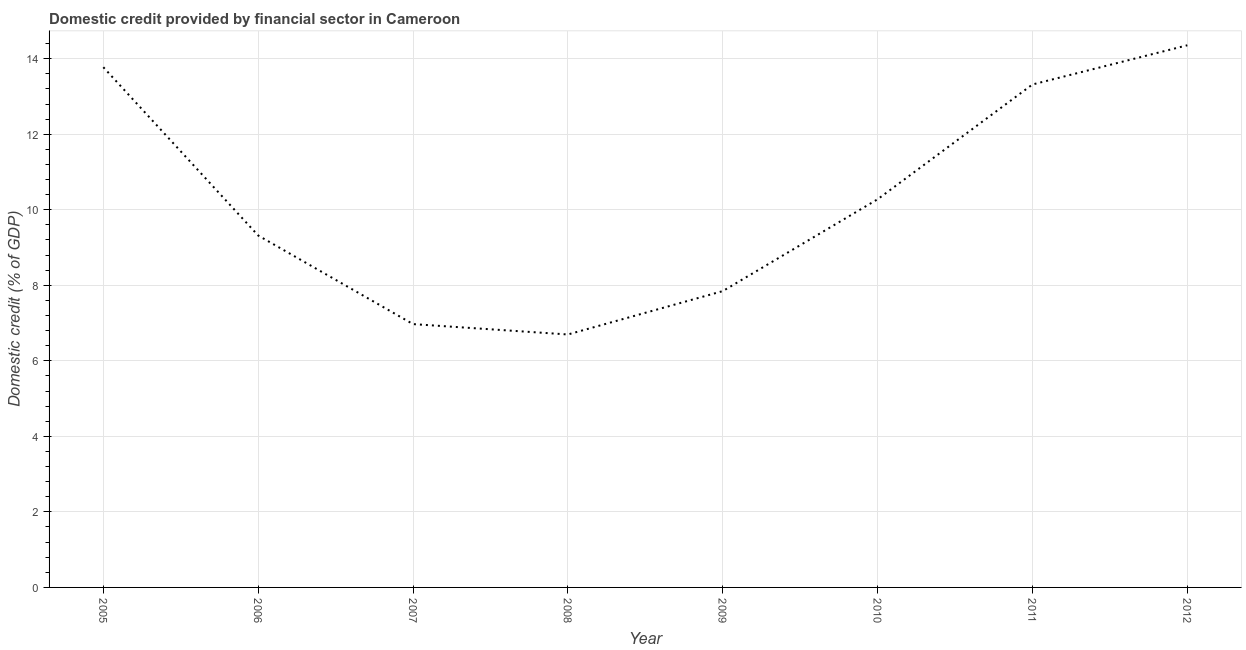What is the domestic credit provided by financial sector in 2010?
Provide a short and direct response. 10.28. Across all years, what is the maximum domestic credit provided by financial sector?
Provide a short and direct response. 14.35. Across all years, what is the minimum domestic credit provided by financial sector?
Provide a succinct answer. 6.7. In which year was the domestic credit provided by financial sector maximum?
Give a very brief answer. 2012. What is the sum of the domestic credit provided by financial sector?
Ensure brevity in your answer.  82.56. What is the difference between the domestic credit provided by financial sector in 2005 and 2011?
Your answer should be compact. 0.46. What is the average domestic credit provided by financial sector per year?
Offer a very short reply. 10.32. What is the median domestic credit provided by financial sector?
Provide a succinct answer. 9.8. In how many years, is the domestic credit provided by financial sector greater than 10.4 %?
Make the answer very short. 3. Do a majority of the years between 2012 and 2008 (inclusive) have domestic credit provided by financial sector greater than 8 %?
Ensure brevity in your answer.  Yes. What is the ratio of the domestic credit provided by financial sector in 2008 to that in 2011?
Your answer should be very brief. 0.5. Is the domestic credit provided by financial sector in 2005 less than that in 2011?
Keep it short and to the point. No. Is the difference between the domestic credit provided by financial sector in 2009 and 2012 greater than the difference between any two years?
Make the answer very short. No. What is the difference between the highest and the second highest domestic credit provided by financial sector?
Ensure brevity in your answer.  0.58. What is the difference between the highest and the lowest domestic credit provided by financial sector?
Keep it short and to the point. 7.66. In how many years, is the domestic credit provided by financial sector greater than the average domestic credit provided by financial sector taken over all years?
Give a very brief answer. 3. Does the domestic credit provided by financial sector monotonically increase over the years?
Ensure brevity in your answer.  No. How many lines are there?
Your answer should be compact. 1. Does the graph contain any zero values?
Your answer should be compact. No. Does the graph contain grids?
Provide a short and direct response. Yes. What is the title of the graph?
Give a very brief answer. Domestic credit provided by financial sector in Cameroon. What is the label or title of the Y-axis?
Give a very brief answer. Domestic credit (% of GDP). What is the Domestic credit (% of GDP) in 2005?
Your answer should be very brief. 13.77. What is the Domestic credit (% of GDP) of 2006?
Your response must be concise. 9.32. What is the Domestic credit (% of GDP) in 2007?
Provide a short and direct response. 6.97. What is the Domestic credit (% of GDP) in 2008?
Your answer should be compact. 6.7. What is the Domestic credit (% of GDP) in 2009?
Give a very brief answer. 7.85. What is the Domestic credit (% of GDP) of 2010?
Your response must be concise. 10.28. What is the Domestic credit (% of GDP) of 2011?
Offer a very short reply. 13.32. What is the Domestic credit (% of GDP) of 2012?
Make the answer very short. 14.35. What is the difference between the Domestic credit (% of GDP) in 2005 and 2006?
Make the answer very short. 4.46. What is the difference between the Domestic credit (% of GDP) in 2005 and 2007?
Your answer should be compact. 6.8. What is the difference between the Domestic credit (% of GDP) in 2005 and 2008?
Keep it short and to the point. 7.08. What is the difference between the Domestic credit (% of GDP) in 2005 and 2009?
Provide a succinct answer. 5.93. What is the difference between the Domestic credit (% of GDP) in 2005 and 2010?
Your response must be concise. 3.5. What is the difference between the Domestic credit (% of GDP) in 2005 and 2011?
Give a very brief answer. 0.46. What is the difference between the Domestic credit (% of GDP) in 2005 and 2012?
Your answer should be very brief. -0.58. What is the difference between the Domestic credit (% of GDP) in 2006 and 2007?
Provide a succinct answer. 2.35. What is the difference between the Domestic credit (% of GDP) in 2006 and 2008?
Make the answer very short. 2.62. What is the difference between the Domestic credit (% of GDP) in 2006 and 2009?
Provide a short and direct response. 1.47. What is the difference between the Domestic credit (% of GDP) in 2006 and 2010?
Your answer should be compact. -0.96. What is the difference between the Domestic credit (% of GDP) in 2006 and 2011?
Keep it short and to the point. -4. What is the difference between the Domestic credit (% of GDP) in 2006 and 2012?
Ensure brevity in your answer.  -5.04. What is the difference between the Domestic credit (% of GDP) in 2007 and 2008?
Your response must be concise. 0.27. What is the difference between the Domestic credit (% of GDP) in 2007 and 2009?
Your answer should be very brief. -0.87. What is the difference between the Domestic credit (% of GDP) in 2007 and 2010?
Provide a short and direct response. -3.31. What is the difference between the Domestic credit (% of GDP) in 2007 and 2011?
Offer a very short reply. -6.34. What is the difference between the Domestic credit (% of GDP) in 2007 and 2012?
Your answer should be very brief. -7.38. What is the difference between the Domestic credit (% of GDP) in 2008 and 2009?
Ensure brevity in your answer.  -1.15. What is the difference between the Domestic credit (% of GDP) in 2008 and 2010?
Your answer should be compact. -3.58. What is the difference between the Domestic credit (% of GDP) in 2008 and 2011?
Provide a succinct answer. -6.62. What is the difference between the Domestic credit (% of GDP) in 2008 and 2012?
Ensure brevity in your answer.  -7.66. What is the difference between the Domestic credit (% of GDP) in 2009 and 2010?
Ensure brevity in your answer.  -2.43. What is the difference between the Domestic credit (% of GDP) in 2009 and 2011?
Offer a terse response. -5.47. What is the difference between the Domestic credit (% of GDP) in 2009 and 2012?
Give a very brief answer. -6.51. What is the difference between the Domestic credit (% of GDP) in 2010 and 2011?
Ensure brevity in your answer.  -3.04. What is the difference between the Domestic credit (% of GDP) in 2010 and 2012?
Offer a terse response. -4.08. What is the difference between the Domestic credit (% of GDP) in 2011 and 2012?
Your answer should be compact. -1.04. What is the ratio of the Domestic credit (% of GDP) in 2005 to that in 2006?
Ensure brevity in your answer.  1.48. What is the ratio of the Domestic credit (% of GDP) in 2005 to that in 2007?
Offer a terse response. 1.98. What is the ratio of the Domestic credit (% of GDP) in 2005 to that in 2008?
Keep it short and to the point. 2.06. What is the ratio of the Domestic credit (% of GDP) in 2005 to that in 2009?
Make the answer very short. 1.76. What is the ratio of the Domestic credit (% of GDP) in 2005 to that in 2010?
Make the answer very short. 1.34. What is the ratio of the Domestic credit (% of GDP) in 2005 to that in 2011?
Your answer should be very brief. 1.03. What is the ratio of the Domestic credit (% of GDP) in 2006 to that in 2007?
Provide a succinct answer. 1.34. What is the ratio of the Domestic credit (% of GDP) in 2006 to that in 2008?
Ensure brevity in your answer.  1.39. What is the ratio of the Domestic credit (% of GDP) in 2006 to that in 2009?
Make the answer very short. 1.19. What is the ratio of the Domestic credit (% of GDP) in 2006 to that in 2010?
Your answer should be compact. 0.91. What is the ratio of the Domestic credit (% of GDP) in 2006 to that in 2012?
Offer a terse response. 0.65. What is the ratio of the Domestic credit (% of GDP) in 2007 to that in 2008?
Ensure brevity in your answer.  1.04. What is the ratio of the Domestic credit (% of GDP) in 2007 to that in 2009?
Keep it short and to the point. 0.89. What is the ratio of the Domestic credit (% of GDP) in 2007 to that in 2010?
Ensure brevity in your answer.  0.68. What is the ratio of the Domestic credit (% of GDP) in 2007 to that in 2011?
Keep it short and to the point. 0.52. What is the ratio of the Domestic credit (% of GDP) in 2007 to that in 2012?
Make the answer very short. 0.49. What is the ratio of the Domestic credit (% of GDP) in 2008 to that in 2009?
Keep it short and to the point. 0.85. What is the ratio of the Domestic credit (% of GDP) in 2008 to that in 2010?
Offer a very short reply. 0.65. What is the ratio of the Domestic credit (% of GDP) in 2008 to that in 2011?
Make the answer very short. 0.5. What is the ratio of the Domestic credit (% of GDP) in 2008 to that in 2012?
Your response must be concise. 0.47. What is the ratio of the Domestic credit (% of GDP) in 2009 to that in 2010?
Offer a very short reply. 0.76. What is the ratio of the Domestic credit (% of GDP) in 2009 to that in 2011?
Make the answer very short. 0.59. What is the ratio of the Domestic credit (% of GDP) in 2009 to that in 2012?
Provide a succinct answer. 0.55. What is the ratio of the Domestic credit (% of GDP) in 2010 to that in 2011?
Offer a very short reply. 0.77. What is the ratio of the Domestic credit (% of GDP) in 2010 to that in 2012?
Offer a terse response. 0.72. What is the ratio of the Domestic credit (% of GDP) in 2011 to that in 2012?
Make the answer very short. 0.93. 